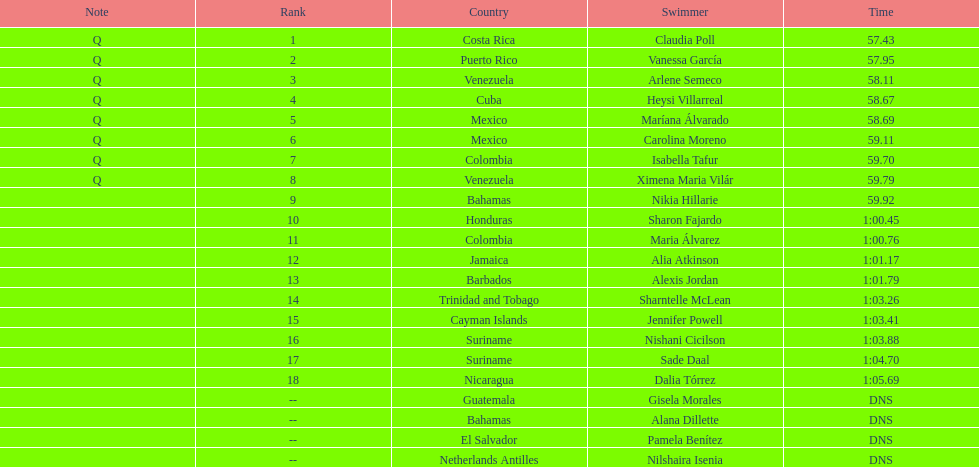Who were all of the swimmers in the women's 100 metre freestyle? Claudia Poll, Vanessa García, Arlene Semeco, Heysi Villarreal, Maríana Álvarado, Carolina Moreno, Isabella Tafur, Ximena Maria Vilár, Nikia Hillarie, Sharon Fajardo, Maria Álvarez, Alia Atkinson, Alexis Jordan, Sharntelle McLean, Jennifer Powell, Nishani Cicilson, Sade Daal, Dalia Tórrez, Gisela Morales, Alana Dillette, Pamela Benítez, Nilshaira Isenia. Where was each swimmer from? Costa Rica, Puerto Rico, Venezuela, Cuba, Mexico, Mexico, Colombia, Venezuela, Bahamas, Honduras, Colombia, Jamaica, Barbados, Trinidad and Tobago, Cayman Islands, Suriname, Suriname, Nicaragua, Guatemala, Bahamas, El Salvador, Netherlands Antilles. What were their ranks? 1, 2, 3, 4, 5, 6, 7, 8, 9, 10, 11, 12, 13, 14, 15, 16, 17, 18, --, --, --, --. Who was in the top eight? Claudia Poll, Vanessa García, Arlene Semeco, Heysi Villarreal, Maríana Álvarado, Carolina Moreno, Isabella Tafur, Ximena Maria Vilár. Of those swimmers, which one was from cuba? Heysi Villarreal. 